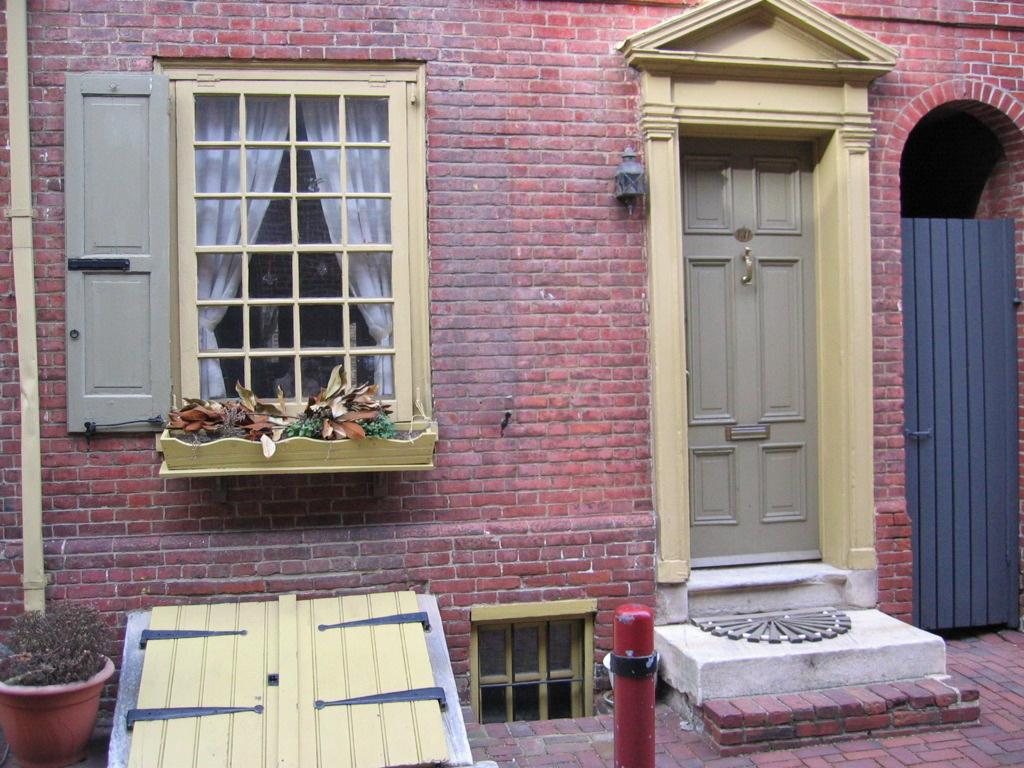What type of plant is in the pot on the left side of the image? The facts do not specify the type of plant in the pot. What structure is visible in the image? There is a house in the image. What features does the house have? The house has a door and a window. How many sheep are grazing in the shade near the ocean in the image? There are no sheep, shade, or ocean present in the image. 